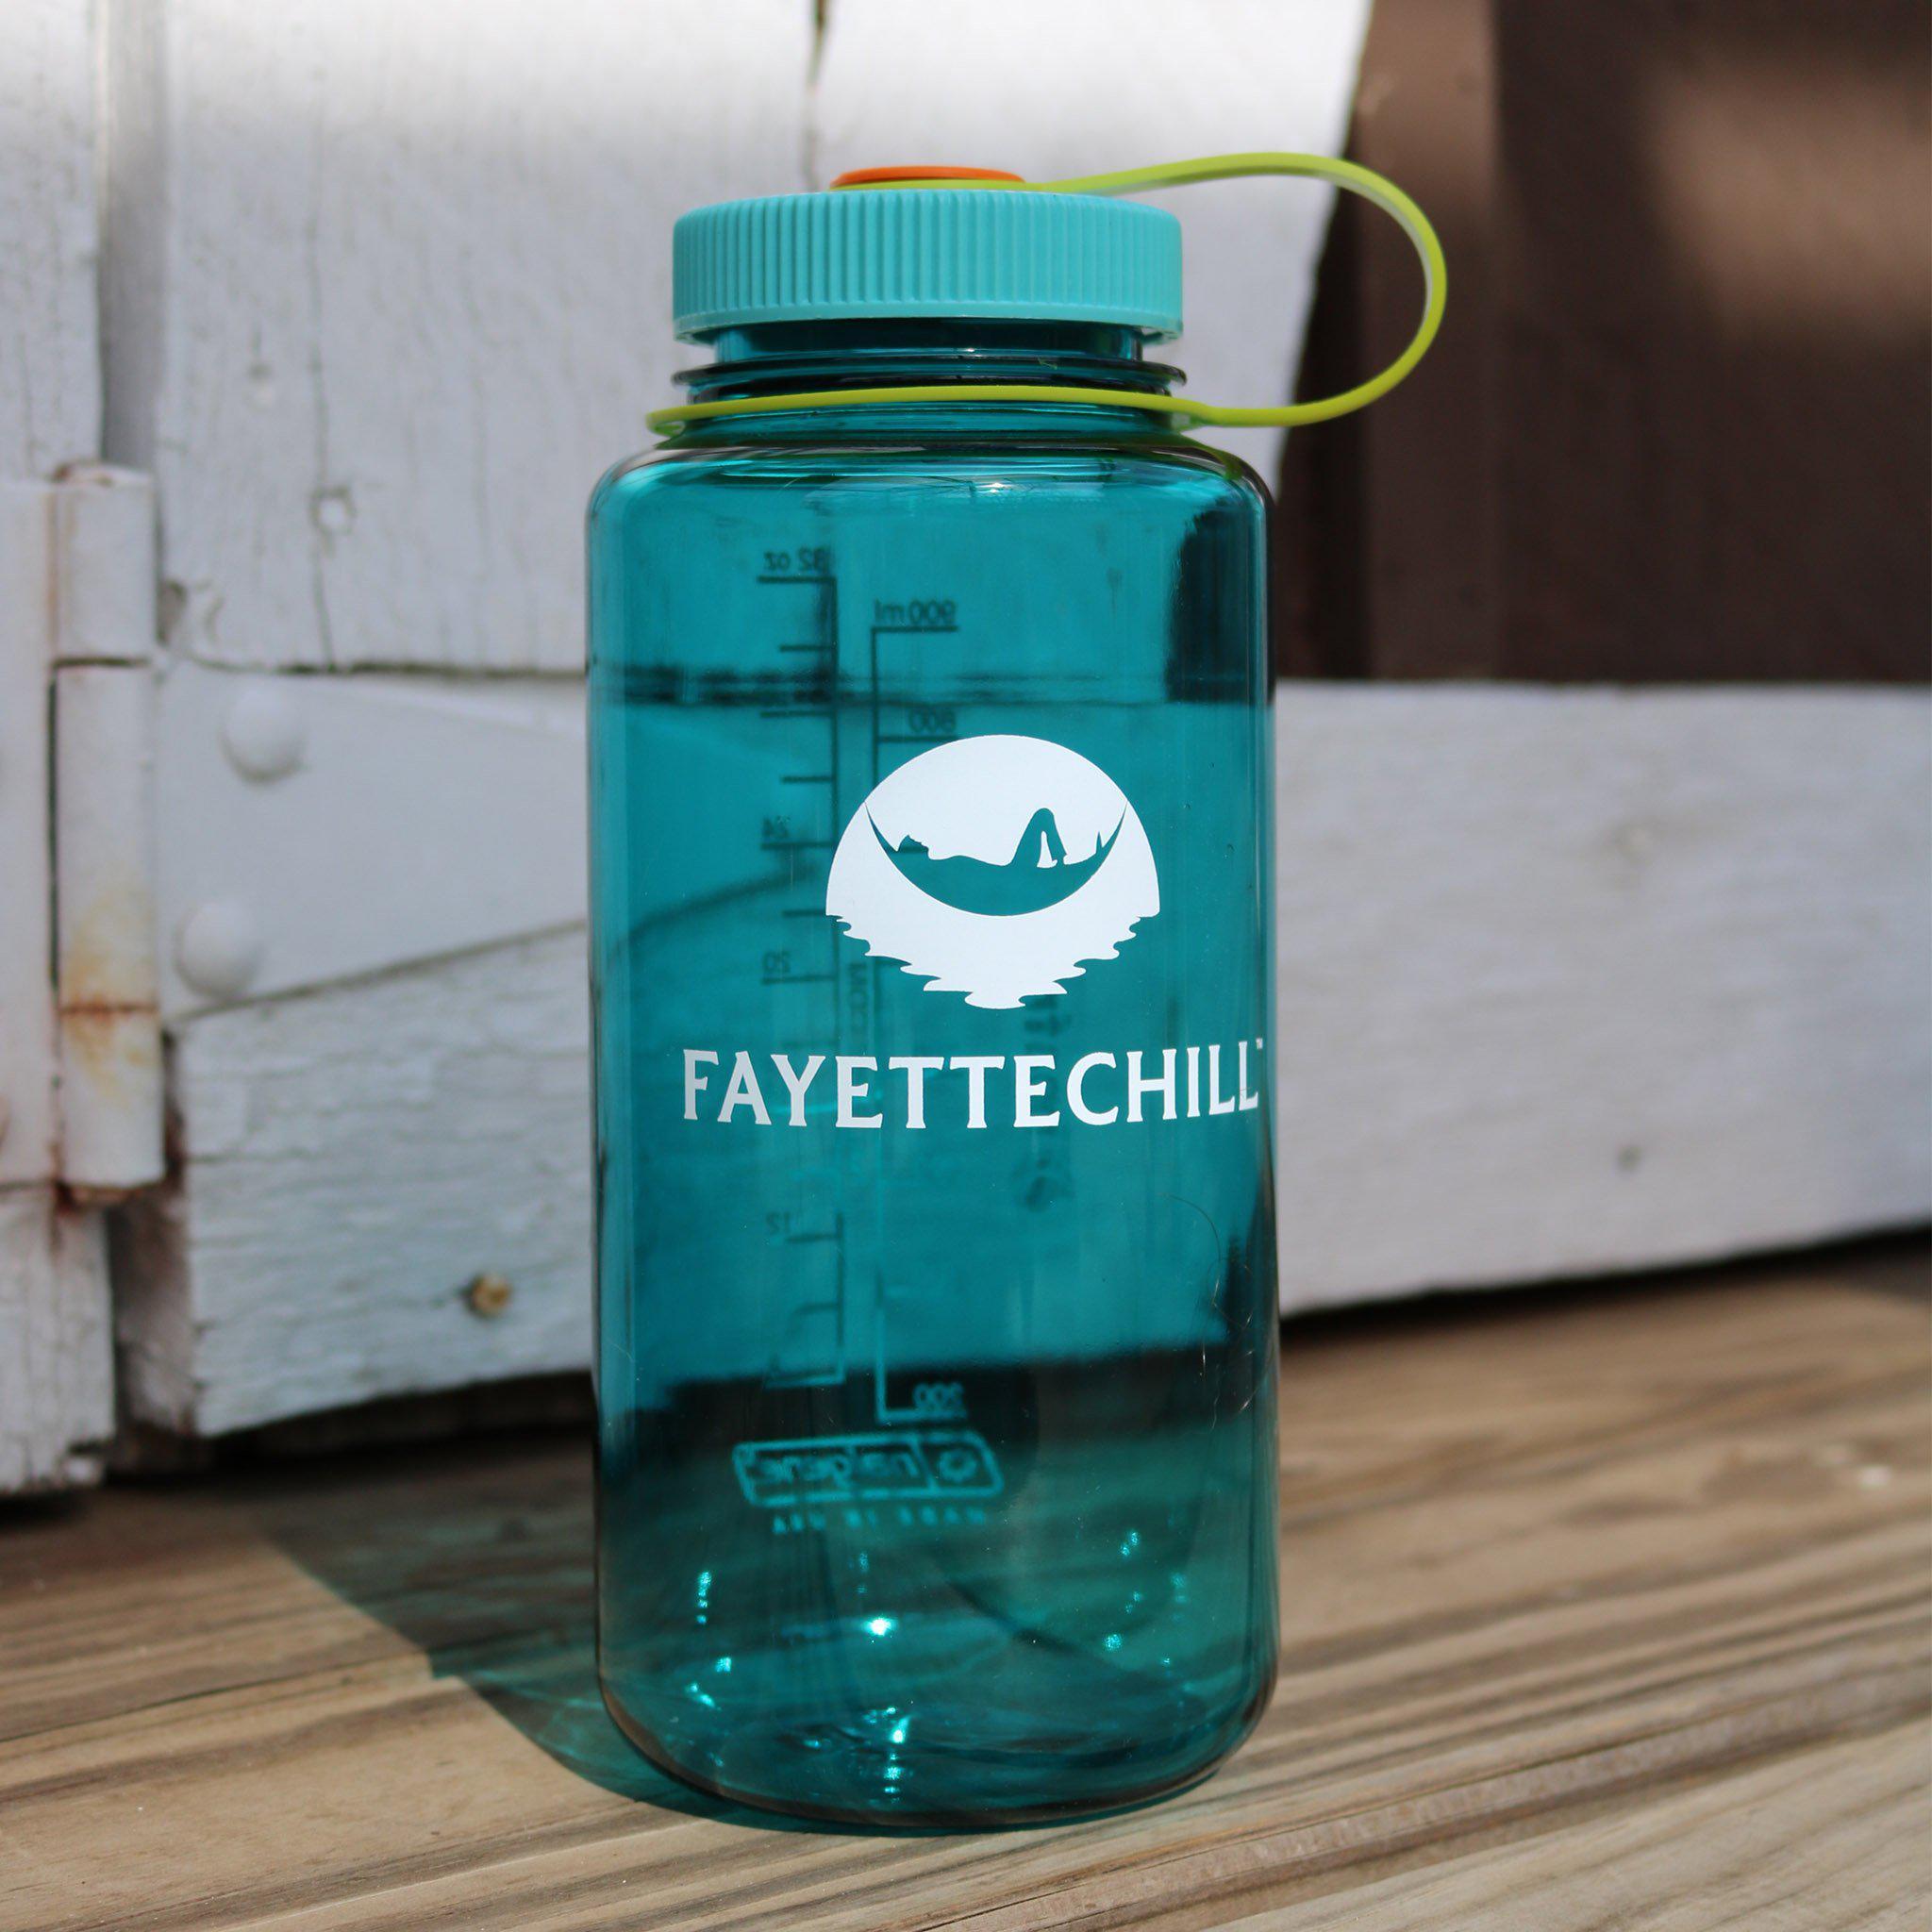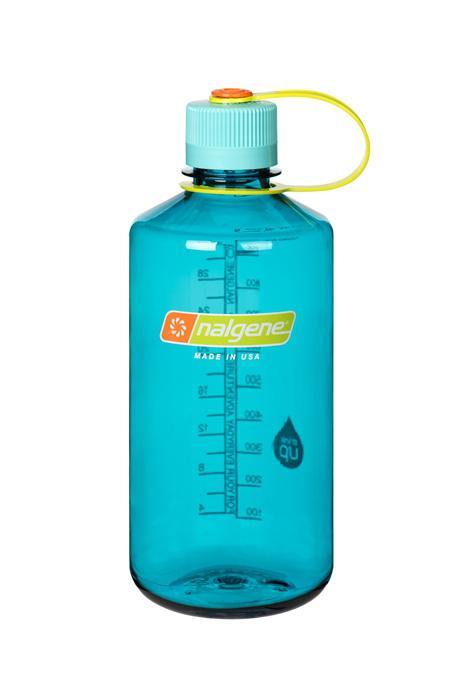The first image is the image on the left, the second image is the image on the right. Analyze the images presented: Is the assertion "One image contains a single water bottle, and the other image contains at least seven water bottles." valid? Answer yes or no. No. The first image is the image on the left, the second image is the image on the right. Analyze the images presented: Is the assertion "The left and right image contains the same number of plastic bottles." valid? Answer yes or no. Yes. 